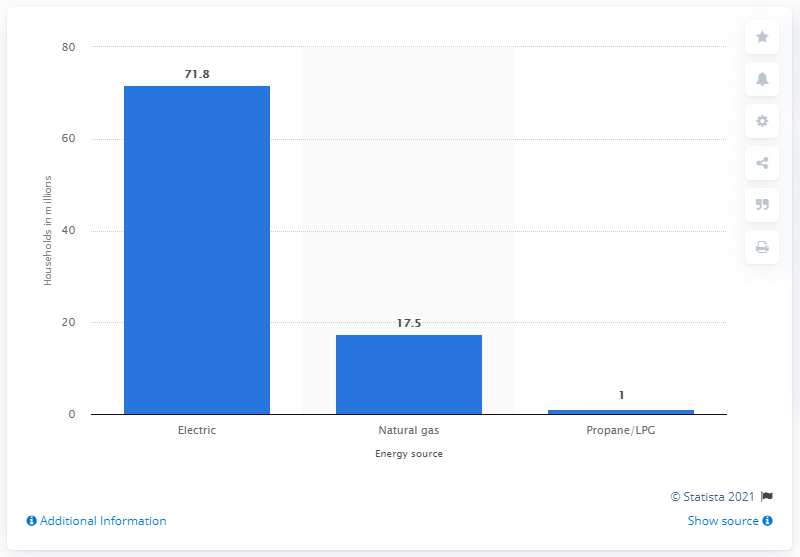Indicate a few pertinent items in this graphic. In 2009, 71.8% of households owned an electric clothes dryer. 